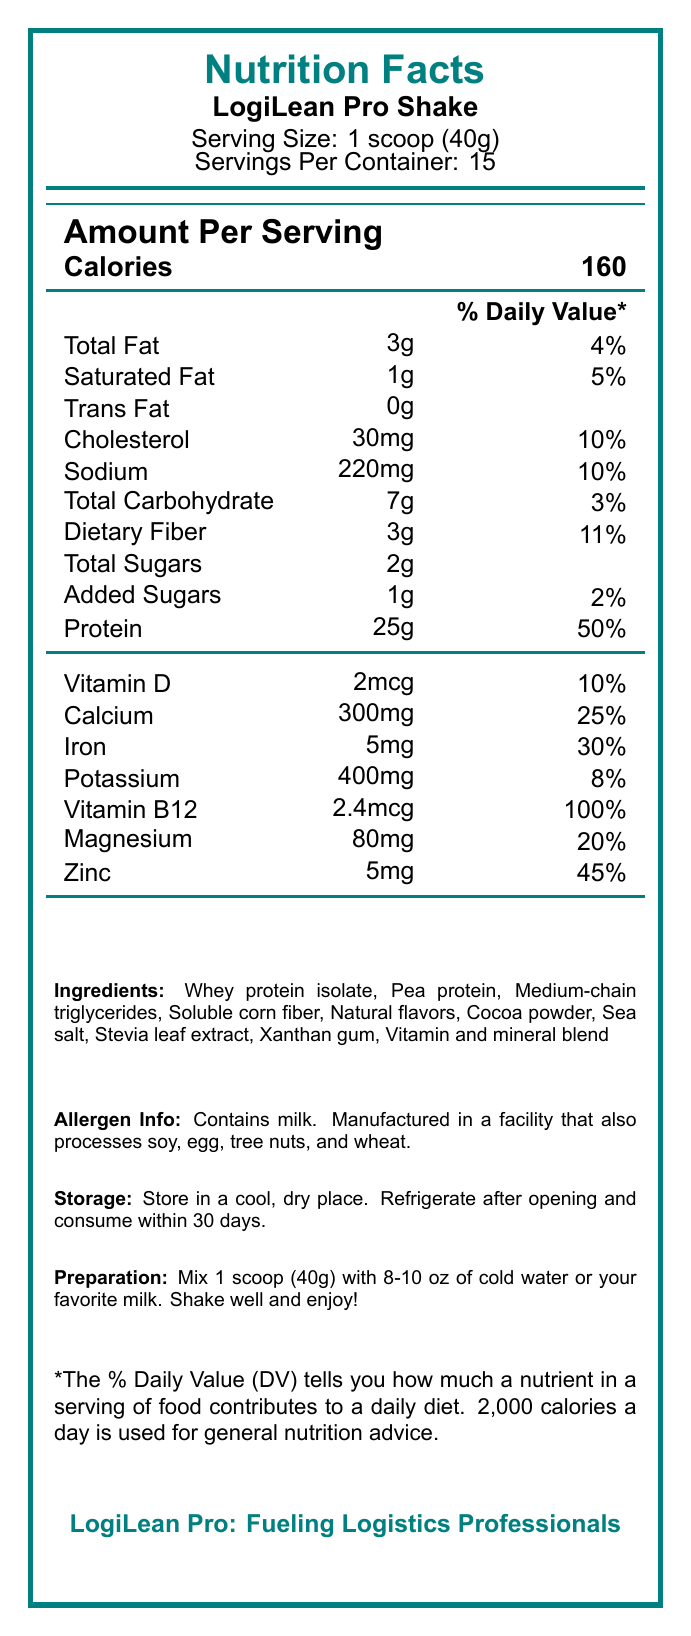what is the serving size for LogiLean Pro Shake? The serving size is specified under the product name as "Serving Size: 1 scoop (40g)".
Answer: 1 scoop (40g) how many servings are there per container? As noted below the serving size, the shake contains "Servings Per Container: 15".
Answer: 15 how many calories are in one serving? The number of calories per serving is indicated in the 'Amount Per Serving' section next to 'Calories'.
Answer: 160 which nutrient has the highest % daily value per serving? A. Calcium B. Dietary Fiber C. Protein D. Vitamin B12 Vitamin B12 has a 100% daily value, which is the highest among the listed nutrients.
Answer: D. Vitamin B12 what is the total amount of fat in each serving? The amount of total fat per serving is listed as "Total Fat: 3g".
Answer: 3g how much sodium is included in one serving? The document states the sodium content as "Sodium: 220mg".
Answer: 220mg is there any trans fat in LogiLean Pro Shake? The serving contains "Trans Fat: 0g", indicating no trans fat.
Answer: No how many grams of dietary fiber are in one serving? The dietary fiber content is listed as "Dietary Fiber: 3g".
Answer: 3g does the LogiLean Pro Shake contain any allergens? The shake contains milk and is manufactured in a facility that processes soy, egg, tree nuts, and wheat.
Answer: Yes what would you find in the ingredients list? The ingredients list is provided at the bottom of the document.
Answer: Whey protein isolate, Pea protein, Medium-chain triglycerides, Soluble corn fiber, Natural flavors, Cocoa powder, Sea salt, Stevia leaf extract, Xanthan gum, Vitamin and mineral blend calculate the total amount of protein in the entire container. Each serving contains 25g of protein, and there are 15 servings per container (25g x 15 = 375g).
Answer: 375g which ingredient is used as a sweetener in the shake? The ingredients list includes "Stevia leaf extract" as a sweetener.
Answer: Stevia leaf extract how should the LogiLean Pro Shake be stored after opening? The storage instructions specify to "Refrigerate after opening and consume within 30 days".
Answer: Refrigerate and consume within 30 days is the shake suitable for someone avoiding dairy? The shake contains milk, which is indicated in the allergen information.
Answer: No what is the main purpose of the LogiLean Pro Shake for professionals? The marketing claims describe the shake as designed for busy logistics professionals with specific benefits like high protein, low sugar, and B12 content for energy.
Answer: It is designed for busy logistics professionals, high in protein to support muscle maintenance, low in sugar to avoid energy crashes, and contains B12 for sustained energy throughout long shifts. what are the daily value percentages for calcium and iron? The daily value percentages for calcium and iron are listed in the vitamins and minerals section.
Answer: Calcium: 25%, Iron: 30% how much added sugar is there in each serving? The document indicates "Added Sugars: 1g".
Answer: 1g which vitamin has the lowest daily value percentage? A. Vitamin D B. Vitamin B12 C. Magnesium D. Potassium Potassium has an 8% daily value, which is the lowest among the listed vitamins and minerals.
Answer: D. Potassium can the document tell us the price of the LogiLean Pro Shake container? There is no information related to pricing in the document.
Answer: No describe the main features of LogiLean Pro Shake as presented in the document. The document outlines the nutritional content, ingredients, allergens, storage, and preparation instructions and emphasizes the shake's advantages for busy professionals.
Answer: LogiLean Pro Shake is a high-protein, low-sugar meal replacement designed for busy logistics professionals. Each serving contains 160 calories, 3g of fat, 25g of protein, 3g of dietary fiber, and 2g of total sugars. It is fortified with essential vitamins and minerals such as Vitamin B12, Calcium, Iron, and Magnesium. The product contains ingredients like Whey protein isolate and Pea protein and carries allergen information about milk. It should be stored in a cool, dry place and refrigerated after opening. The shake claims to support muscle maintenance, enhance energy, and promote satiety during hectic workdays. 